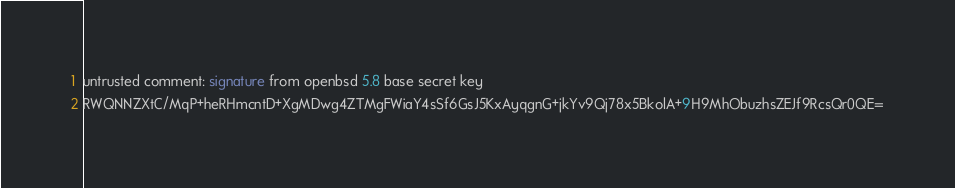<code> <loc_0><loc_0><loc_500><loc_500><_SML_>untrusted comment: signature from openbsd 5.8 base secret key
RWQNNZXtC/MqP+heRHmcntD+XgMDwg4ZTMgFWiaY4sSf6GsJ5KxAyqgnG+jkYv9Qj78x5BkolA+9H9MhObuzhsZEJf9RcsQr0QE=
</code> 